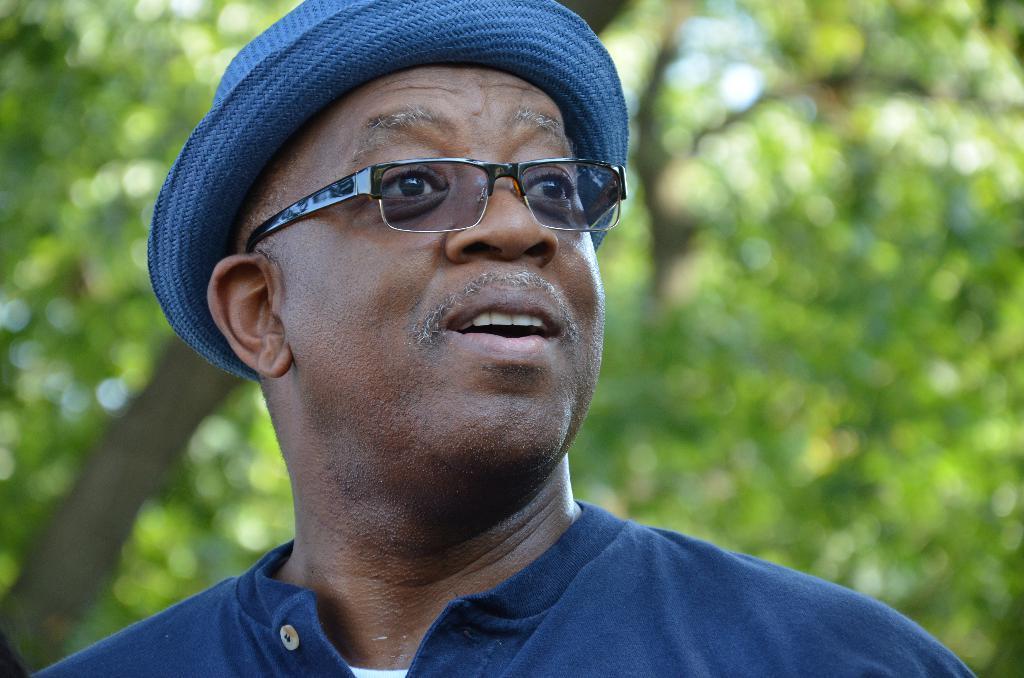Can you describe this image briefly? In this image I can see the person with blue and white color dress and also hat. I can see the person wearing the specs and there are trees in the back. 